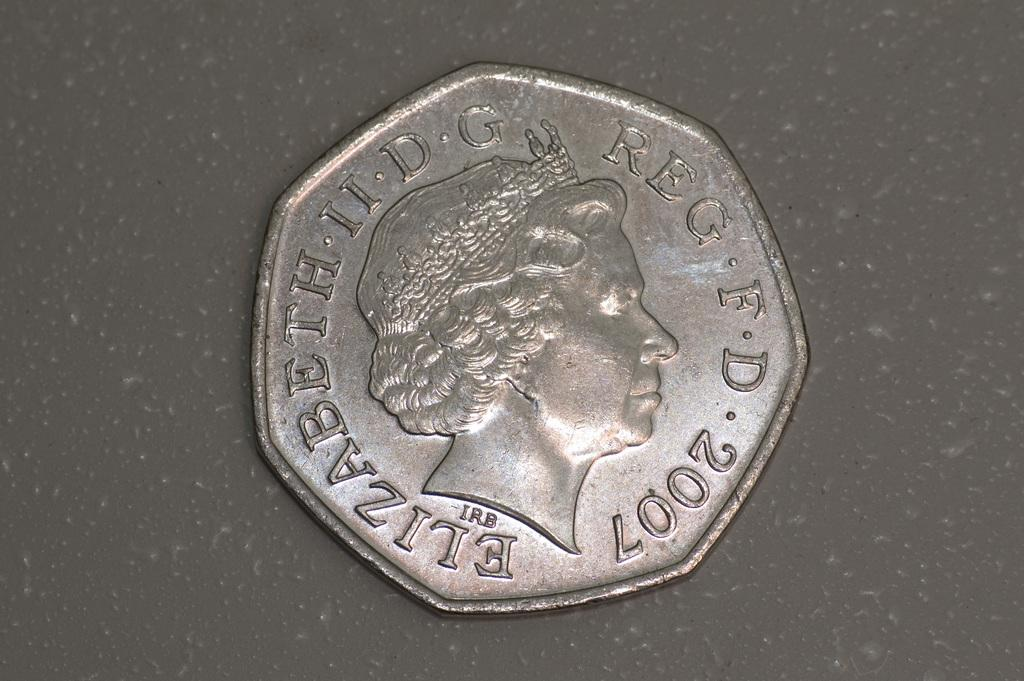<image>
Render a clear and concise summary of the photo. a silver coin that says 'elizabeth ii d g' 